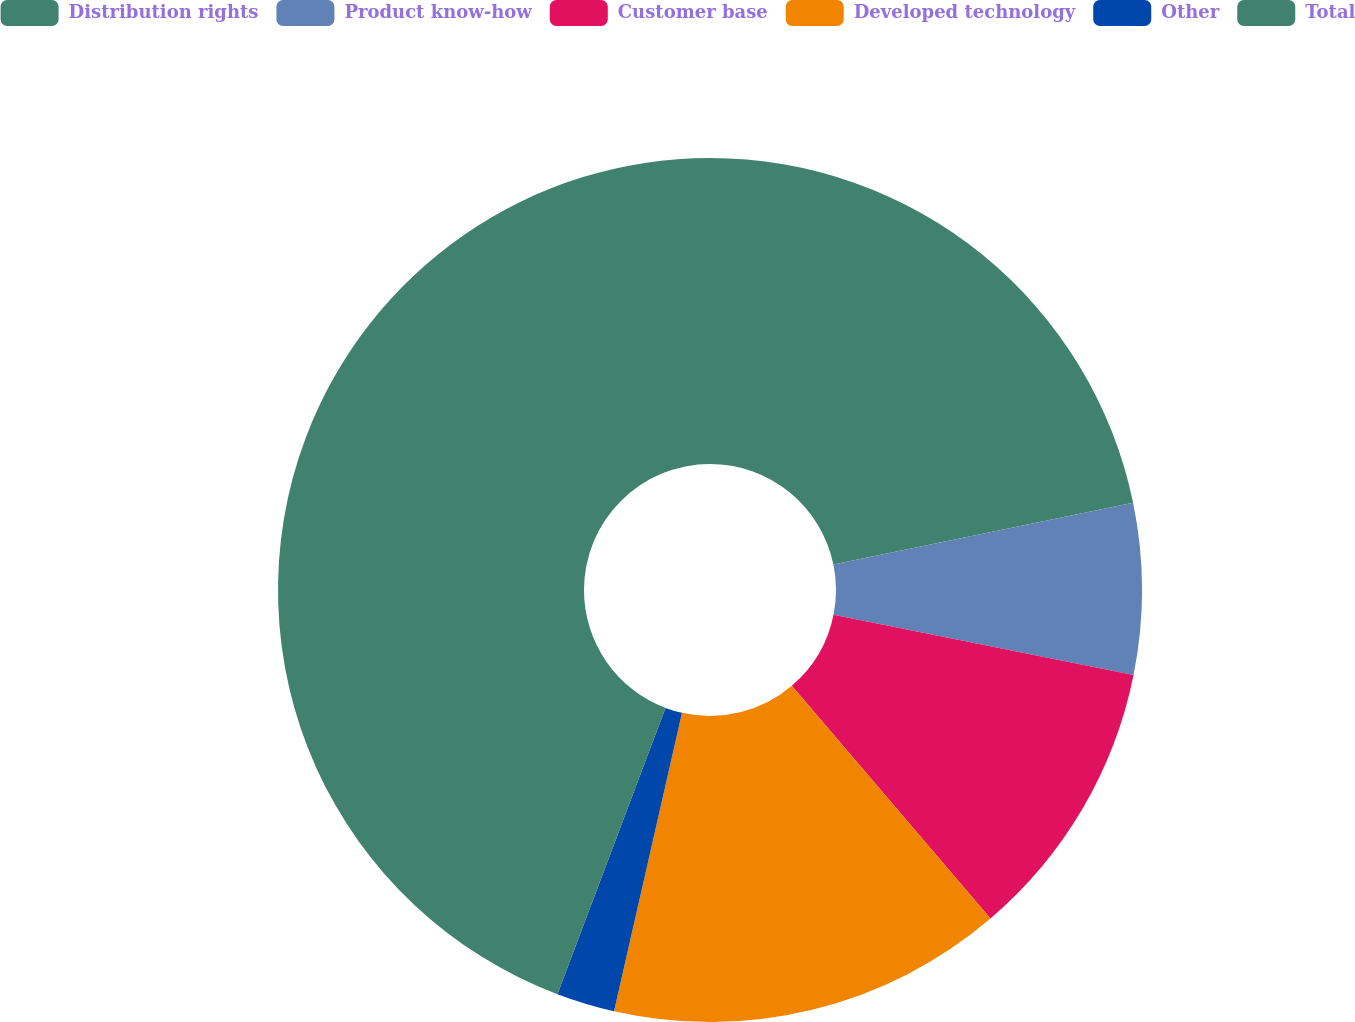<chart> <loc_0><loc_0><loc_500><loc_500><pie_chart><fcel>Distribution rights<fcel>Product know-how<fcel>Customer base<fcel>Developed technology<fcel>Other<fcel>Total<nl><fcel>21.76%<fcel>6.39%<fcel>10.6%<fcel>14.81%<fcel>2.18%<fcel>44.25%<nl></chart> 